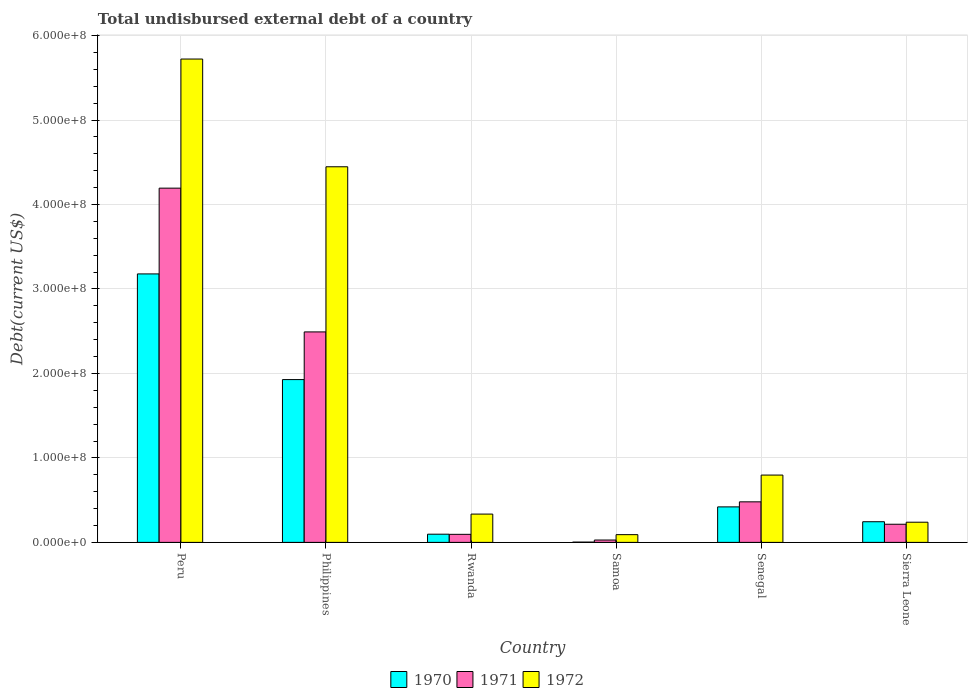How many groups of bars are there?
Offer a very short reply. 6. Are the number of bars on each tick of the X-axis equal?
Provide a short and direct response. Yes. What is the label of the 5th group of bars from the left?
Your answer should be compact. Senegal. In how many cases, is the number of bars for a given country not equal to the number of legend labels?
Your response must be concise. 0. What is the total undisbursed external debt in 1971 in Rwanda?
Keep it short and to the point. 9.53e+06. Across all countries, what is the maximum total undisbursed external debt in 1972?
Provide a short and direct response. 5.72e+08. Across all countries, what is the minimum total undisbursed external debt in 1972?
Provide a short and direct response. 9.15e+06. In which country was the total undisbursed external debt in 1970 minimum?
Offer a very short reply. Samoa. What is the total total undisbursed external debt in 1970 in the graph?
Make the answer very short. 5.87e+08. What is the difference between the total undisbursed external debt in 1972 in Peru and that in Sierra Leone?
Your response must be concise. 5.48e+08. What is the difference between the total undisbursed external debt in 1971 in Senegal and the total undisbursed external debt in 1970 in Rwanda?
Provide a succinct answer. 3.83e+07. What is the average total undisbursed external debt in 1972 per country?
Keep it short and to the point. 1.94e+08. What is the difference between the total undisbursed external debt of/in 1971 and total undisbursed external debt of/in 1972 in Peru?
Make the answer very short. -1.53e+08. What is the ratio of the total undisbursed external debt in 1971 in Samoa to that in Senegal?
Make the answer very short. 0.06. Is the difference between the total undisbursed external debt in 1971 in Peru and Philippines greater than the difference between the total undisbursed external debt in 1972 in Peru and Philippines?
Give a very brief answer. Yes. What is the difference between the highest and the second highest total undisbursed external debt in 1971?
Provide a short and direct response. 1.70e+08. What is the difference between the highest and the lowest total undisbursed external debt in 1971?
Provide a short and direct response. 4.17e+08. In how many countries, is the total undisbursed external debt in 1970 greater than the average total undisbursed external debt in 1970 taken over all countries?
Your answer should be very brief. 2. Is the sum of the total undisbursed external debt in 1971 in Rwanda and Sierra Leone greater than the maximum total undisbursed external debt in 1970 across all countries?
Offer a very short reply. No. What does the 1st bar from the right in Sierra Leone represents?
Provide a succinct answer. 1972. How many countries are there in the graph?
Keep it short and to the point. 6. What is the difference between two consecutive major ticks on the Y-axis?
Your answer should be compact. 1.00e+08. Are the values on the major ticks of Y-axis written in scientific E-notation?
Keep it short and to the point. Yes. Does the graph contain grids?
Your answer should be very brief. Yes. Where does the legend appear in the graph?
Ensure brevity in your answer.  Bottom center. How many legend labels are there?
Provide a succinct answer. 3. What is the title of the graph?
Offer a very short reply. Total undisbursed external debt of a country. What is the label or title of the X-axis?
Your answer should be very brief. Country. What is the label or title of the Y-axis?
Make the answer very short. Debt(current US$). What is the Debt(current US$) in 1970 in Peru?
Your answer should be compact. 3.18e+08. What is the Debt(current US$) of 1971 in Peru?
Your answer should be compact. 4.19e+08. What is the Debt(current US$) of 1972 in Peru?
Ensure brevity in your answer.  5.72e+08. What is the Debt(current US$) of 1970 in Philippines?
Your answer should be very brief. 1.93e+08. What is the Debt(current US$) of 1971 in Philippines?
Your answer should be very brief. 2.49e+08. What is the Debt(current US$) of 1972 in Philippines?
Your answer should be very brief. 4.45e+08. What is the Debt(current US$) of 1970 in Rwanda?
Provide a short and direct response. 9.70e+06. What is the Debt(current US$) in 1971 in Rwanda?
Your answer should be compact. 9.53e+06. What is the Debt(current US$) in 1972 in Rwanda?
Provide a succinct answer. 3.35e+07. What is the Debt(current US$) in 1970 in Samoa?
Offer a very short reply. 3.36e+05. What is the Debt(current US$) in 1971 in Samoa?
Ensure brevity in your answer.  2.80e+06. What is the Debt(current US$) of 1972 in Samoa?
Your answer should be compact. 9.15e+06. What is the Debt(current US$) of 1970 in Senegal?
Offer a terse response. 4.20e+07. What is the Debt(current US$) in 1971 in Senegal?
Keep it short and to the point. 4.80e+07. What is the Debt(current US$) of 1972 in Senegal?
Your response must be concise. 7.97e+07. What is the Debt(current US$) in 1970 in Sierra Leone?
Your response must be concise. 2.45e+07. What is the Debt(current US$) in 1971 in Sierra Leone?
Give a very brief answer. 2.15e+07. What is the Debt(current US$) in 1972 in Sierra Leone?
Make the answer very short. 2.39e+07. Across all countries, what is the maximum Debt(current US$) in 1970?
Make the answer very short. 3.18e+08. Across all countries, what is the maximum Debt(current US$) of 1971?
Provide a short and direct response. 4.19e+08. Across all countries, what is the maximum Debt(current US$) of 1972?
Offer a terse response. 5.72e+08. Across all countries, what is the minimum Debt(current US$) in 1970?
Keep it short and to the point. 3.36e+05. Across all countries, what is the minimum Debt(current US$) in 1971?
Provide a short and direct response. 2.80e+06. Across all countries, what is the minimum Debt(current US$) in 1972?
Give a very brief answer. 9.15e+06. What is the total Debt(current US$) of 1970 in the graph?
Keep it short and to the point. 5.87e+08. What is the total Debt(current US$) in 1971 in the graph?
Keep it short and to the point. 7.50e+08. What is the total Debt(current US$) of 1972 in the graph?
Offer a very short reply. 1.16e+09. What is the difference between the Debt(current US$) in 1970 in Peru and that in Philippines?
Your answer should be very brief. 1.25e+08. What is the difference between the Debt(current US$) in 1971 in Peru and that in Philippines?
Give a very brief answer. 1.70e+08. What is the difference between the Debt(current US$) in 1972 in Peru and that in Philippines?
Your answer should be very brief. 1.28e+08. What is the difference between the Debt(current US$) of 1970 in Peru and that in Rwanda?
Your response must be concise. 3.08e+08. What is the difference between the Debt(current US$) of 1971 in Peru and that in Rwanda?
Provide a succinct answer. 4.10e+08. What is the difference between the Debt(current US$) in 1972 in Peru and that in Rwanda?
Keep it short and to the point. 5.39e+08. What is the difference between the Debt(current US$) in 1970 in Peru and that in Samoa?
Make the answer very short. 3.17e+08. What is the difference between the Debt(current US$) in 1971 in Peru and that in Samoa?
Make the answer very short. 4.17e+08. What is the difference between the Debt(current US$) of 1972 in Peru and that in Samoa?
Give a very brief answer. 5.63e+08. What is the difference between the Debt(current US$) of 1970 in Peru and that in Senegal?
Provide a short and direct response. 2.76e+08. What is the difference between the Debt(current US$) in 1971 in Peru and that in Senegal?
Your response must be concise. 3.71e+08. What is the difference between the Debt(current US$) of 1972 in Peru and that in Senegal?
Your answer should be very brief. 4.92e+08. What is the difference between the Debt(current US$) of 1970 in Peru and that in Sierra Leone?
Provide a short and direct response. 2.93e+08. What is the difference between the Debt(current US$) of 1971 in Peru and that in Sierra Leone?
Ensure brevity in your answer.  3.98e+08. What is the difference between the Debt(current US$) in 1972 in Peru and that in Sierra Leone?
Provide a succinct answer. 5.48e+08. What is the difference between the Debt(current US$) in 1970 in Philippines and that in Rwanda?
Keep it short and to the point. 1.83e+08. What is the difference between the Debt(current US$) of 1971 in Philippines and that in Rwanda?
Offer a very short reply. 2.40e+08. What is the difference between the Debt(current US$) of 1972 in Philippines and that in Rwanda?
Give a very brief answer. 4.11e+08. What is the difference between the Debt(current US$) of 1970 in Philippines and that in Samoa?
Ensure brevity in your answer.  1.92e+08. What is the difference between the Debt(current US$) in 1971 in Philippines and that in Samoa?
Make the answer very short. 2.46e+08. What is the difference between the Debt(current US$) of 1972 in Philippines and that in Samoa?
Your response must be concise. 4.35e+08. What is the difference between the Debt(current US$) of 1970 in Philippines and that in Senegal?
Offer a very short reply. 1.51e+08. What is the difference between the Debt(current US$) in 1971 in Philippines and that in Senegal?
Your response must be concise. 2.01e+08. What is the difference between the Debt(current US$) in 1972 in Philippines and that in Senegal?
Offer a terse response. 3.65e+08. What is the difference between the Debt(current US$) in 1970 in Philippines and that in Sierra Leone?
Offer a terse response. 1.68e+08. What is the difference between the Debt(current US$) of 1971 in Philippines and that in Sierra Leone?
Ensure brevity in your answer.  2.28e+08. What is the difference between the Debt(current US$) of 1972 in Philippines and that in Sierra Leone?
Offer a terse response. 4.21e+08. What is the difference between the Debt(current US$) of 1970 in Rwanda and that in Samoa?
Offer a very short reply. 9.36e+06. What is the difference between the Debt(current US$) of 1971 in Rwanda and that in Samoa?
Your answer should be very brief. 6.73e+06. What is the difference between the Debt(current US$) in 1972 in Rwanda and that in Samoa?
Your response must be concise. 2.43e+07. What is the difference between the Debt(current US$) in 1970 in Rwanda and that in Senegal?
Ensure brevity in your answer.  -3.23e+07. What is the difference between the Debt(current US$) in 1971 in Rwanda and that in Senegal?
Your answer should be compact. -3.85e+07. What is the difference between the Debt(current US$) of 1972 in Rwanda and that in Senegal?
Offer a terse response. -4.62e+07. What is the difference between the Debt(current US$) in 1970 in Rwanda and that in Sierra Leone?
Offer a terse response. -1.48e+07. What is the difference between the Debt(current US$) of 1971 in Rwanda and that in Sierra Leone?
Offer a very short reply. -1.19e+07. What is the difference between the Debt(current US$) in 1972 in Rwanda and that in Sierra Leone?
Provide a short and direct response. 9.62e+06. What is the difference between the Debt(current US$) in 1970 in Samoa and that in Senegal?
Make the answer very short. -4.17e+07. What is the difference between the Debt(current US$) in 1971 in Samoa and that in Senegal?
Provide a succinct answer. -4.52e+07. What is the difference between the Debt(current US$) of 1972 in Samoa and that in Senegal?
Provide a short and direct response. -7.05e+07. What is the difference between the Debt(current US$) in 1970 in Samoa and that in Sierra Leone?
Keep it short and to the point. -2.41e+07. What is the difference between the Debt(current US$) in 1971 in Samoa and that in Sierra Leone?
Give a very brief answer. -1.87e+07. What is the difference between the Debt(current US$) in 1972 in Samoa and that in Sierra Leone?
Provide a succinct answer. -1.47e+07. What is the difference between the Debt(current US$) of 1970 in Senegal and that in Sierra Leone?
Your answer should be very brief. 1.76e+07. What is the difference between the Debt(current US$) of 1971 in Senegal and that in Sierra Leone?
Your answer should be very brief. 2.65e+07. What is the difference between the Debt(current US$) in 1972 in Senegal and that in Sierra Leone?
Give a very brief answer. 5.58e+07. What is the difference between the Debt(current US$) of 1970 in Peru and the Debt(current US$) of 1971 in Philippines?
Offer a very short reply. 6.86e+07. What is the difference between the Debt(current US$) of 1970 in Peru and the Debt(current US$) of 1972 in Philippines?
Make the answer very short. -1.27e+08. What is the difference between the Debt(current US$) in 1971 in Peru and the Debt(current US$) in 1972 in Philippines?
Ensure brevity in your answer.  -2.53e+07. What is the difference between the Debt(current US$) in 1970 in Peru and the Debt(current US$) in 1971 in Rwanda?
Make the answer very short. 3.08e+08. What is the difference between the Debt(current US$) in 1970 in Peru and the Debt(current US$) in 1972 in Rwanda?
Provide a short and direct response. 2.84e+08. What is the difference between the Debt(current US$) of 1971 in Peru and the Debt(current US$) of 1972 in Rwanda?
Give a very brief answer. 3.86e+08. What is the difference between the Debt(current US$) of 1970 in Peru and the Debt(current US$) of 1971 in Samoa?
Provide a short and direct response. 3.15e+08. What is the difference between the Debt(current US$) in 1970 in Peru and the Debt(current US$) in 1972 in Samoa?
Offer a very short reply. 3.09e+08. What is the difference between the Debt(current US$) of 1971 in Peru and the Debt(current US$) of 1972 in Samoa?
Keep it short and to the point. 4.10e+08. What is the difference between the Debt(current US$) of 1970 in Peru and the Debt(current US$) of 1971 in Senegal?
Give a very brief answer. 2.70e+08. What is the difference between the Debt(current US$) in 1970 in Peru and the Debt(current US$) in 1972 in Senegal?
Provide a short and direct response. 2.38e+08. What is the difference between the Debt(current US$) in 1971 in Peru and the Debt(current US$) in 1972 in Senegal?
Make the answer very short. 3.40e+08. What is the difference between the Debt(current US$) in 1970 in Peru and the Debt(current US$) in 1971 in Sierra Leone?
Your response must be concise. 2.96e+08. What is the difference between the Debt(current US$) in 1970 in Peru and the Debt(current US$) in 1972 in Sierra Leone?
Provide a succinct answer. 2.94e+08. What is the difference between the Debt(current US$) of 1971 in Peru and the Debt(current US$) of 1972 in Sierra Leone?
Your answer should be compact. 3.95e+08. What is the difference between the Debt(current US$) in 1970 in Philippines and the Debt(current US$) in 1971 in Rwanda?
Your response must be concise. 1.83e+08. What is the difference between the Debt(current US$) of 1970 in Philippines and the Debt(current US$) of 1972 in Rwanda?
Provide a succinct answer. 1.59e+08. What is the difference between the Debt(current US$) in 1971 in Philippines and the Debt(current US$) in 1972 in Rwanda?
Make the answer very short. 2.16e+08. What is the difference between the Debt(current US$) of 1970 in Philippines and the Debt(current US$) of 1971 in Samoa?
Your response must be concise. 1.90e+08. What is the difference between the Debt(current US$) of 1970 in Philippines and the Debt(current US$) of 1972 in Samoa?
Your answer should be very brief. 1.84e+08. What is the difference between the Debt(current US$) of 1971 in Philippines and the Debt(current US$) of 1972 in Samoa?
Offer a very short reply. 2.40e+08. What is the difference between the Debt(current US$) of 1970 in Philippines and the Debt(current US$) of 1971 in Senegal?
Provide a short and direct response. 1.45e+08. What is the difference between the Debt(current US$) of 1970 in Philippines and the Debt(current US$) of 1972 in Senegal?
Keep it short and to the point. 1.13e+08. What is the difference between the Debt(current US$) in 1971 in Philippines and the Debt(current US$) in 1972 in Senegal?
Your answer should be very brief. 1.69e+08. What is the difference between the Debt(current US$) of 1970 in Philippines and the Debt(current US$) of 1971 in Sierra Leone?
Keep it short and to the point. 1.71e+08. What is the difference between the Debt(current US$) of 1970 in Philippines and the Debt(current US$) of 1972 in Sierra Leone?
Your response must be concise. 1.69e+08. What is the difference between the Debt(current US$) of 1971 in Philippines and the Debt(current US$) of 1972 in Sierra Leone?
Keep it short and to the point. 2.25e+08. What is the difference between the Debt(current US$) in 1970 in Rwanda and the Debt(current US$) in 1971 in Samoa?
Keep it short and to the point. 6.90e+06. What is the difference between the Debt(current US$) of 1970 in Rwanda and the Debt(current US$) of 1972 in Samoa?
Ensure brevity in your answer.  5.45e+05. What is the difference between the Debt(current US$) of 1971 in Rwanda and the Debt(current US$) of 1972 in Samoa?
Offer a terse response. 3.82e+05. What is the difference between the Debt(current US$) of 1970 in Rwanda and the Debt(current US$) of 1971 in Senegal?
Your answer should be very brief. -3.83e+07. What is the difference between the Debt(current US$) of 1970 in Rwanda and the Debt(current US$) of 1972 in Senegal?
Provide a succinct answer. -7.00e+07. What is the difference between the Debt(current US$) of 1971 in Rwanda and the Debt(current US$) of 1972 in Senegal?
Offer a terse response. -7.02e+07. What is the difference between the Debt(current US$) of 1970 in Rwanda and the Debt(current US$) of 1971 in Sierra Leone?
Provide a short and direct response. -1.18e+07. What is the difference between the Debt(current US$) of 1970 in Rwanda and the Debt(current US$) of 1972 in Sierra Leone?
Ensure brevity in your answer.  -1.42e+07. What is the difference between the Debt(current US$) in 1971 in Rwanda and the Debt(current US$) in 1972 in Sierra Leone?
Your answer should be compact. -1.43e+07. What is the difference between the Debt(current US$) of 1970 in Samoa and the Debt(current US$) of 1971 in Senegal?
Your response must be concise. -4.77e+07. What is the difference between the Debt(current US$) of 1970 in Samoa and the Debt(current US$) of 1972 in Senegal?
Your response must be concise. -7.93e+07. What is the difference between the Debt(current US$) in 1971 in Samoa and the Debt(current US$) in 1972 in Senegal?
Ensure brevity in your answer.  -7.69e+07. What is the difference between the Debt(current US$) in 1970 in Samoa and the Debt(current US$) in 1971 in Sierra Leone?
Your answer should be compact. -2.11e+07. What is the difference between the Debt(current US$) of 1970 in Samoa and the Debt(current US$) of 1972 in Sierra Leone?
Make the answer very short. -2.35e+07. What is the difference between the Debt(current US$) of 1971 in Samoa and the Debt(current US$) of 1972 in Sierra Leone?
Your response must be concise. -2.11e+07. What is the difference between the Debt(current US$) in 1970 in Senegal and the Debt(current US$) in 1971 in Sierra Leone?
Ensure brevity in your answer.  2.05e+07. What is the difference between the Debt(current US$) in 1970 in Senegal and the Debt(current US$) in 1972 in Sierra Leone?
Make the answer very short. 1.82e+07. What is the difference between the Debt(current US$) of 1971 in Senegal and the Debt(current US$) of 1972 in Sierra Leone?
Offer a very short reply. 2.41e+07. What is the average Debt(current US$) of 1970 per country?
Offer a very short reply. 9.78e+07. What is the average Debt(current US$) in 1971 per country?
Ensure brevity in your answer.  1.25e+08. What is the average Debt(current US$) in 1972 per country?
Offer a terse response. 1.94e+08. What is the difference between the Debt(current US$) in 1970 and Debt(current US$) in 1971 in Peru?
Offer a terse response. -1.02e+08. What is the difference between the Debt(current US$) in 1970 and Debt(current US$) in 1972 in Peru?
Offer a terse response. -2.54e+08. What is the difference between the Debt(current US$) of 1971 and Debt(current US$) of 1972 in Peru?
Ensure brevity in your answer.  -1.53e+08. What is the difference between the Debt(current US$) of 1970 and Debt(current US$) of 1971 in Philippines?
Offer a terse response. -5.64e+07. What is the difference between the Debt(current US$) of 1970 and Debt(current US$) of 1972 in Philippines?
Ensure brevity in your answer.  -2.52e+08. What is the difference between the Debt(current US$) in 1971 and Debt(current US$) in 1972 in Philippines?
Offer a terse response. -1.95e+08. What is the difference between the Debt(current US$) of 1970 and Debt(current US$) of 1971 in Rwanda?
Offer a terse response. 1.63e+05. What is the difference between the Debt(current US$) of 1970 and Debt(current US$) of 1972 in Rwanda?
Offer a terse response. -2.38e+07. What is the difference between the Debt(current US$) in 1971 and Debt(current US$) in 1972 in Rwanda?
Offer a terse response. -2.40e+07. What is the difference between the Debt(current US$) of 1970 and Debt(current US$) of 1971 in Samoa?
Offer a very short reply. -2.46e+06. What is the difference between the Debt(current US$) of 1970 and Debt(current US$) of 1972 in Samoa?
Keep it short and to the point. -8.82e+06. What is the difference between the Debt(current US$) in 1971 and Debt(current US$) in 1972 in Samoa?
Your response must be concise. -6.35e+06. What is the difference between the Debt(current US$) in 1970 and Debt(current US$) in 1971 in Senegal?
Offer a very short reply. -5.97e+06. What is the difference between the Debt(current US$) of 1970 and Debt(current US$) of 1972 in Senegal?
Your response must be concise. -3.77e+07. What is the difference between the Debt(current US$) in 1971 and Debt(current US$) in 1972 in Senegal?
Ensure brevity in your answer.  -3.17e+07. What is the difference between the Debt(current US$) in 1970 and Debt(current US$) in 1971 in Sierra Leone?
Your answer should be very brief. 2.98e+06. What is the difference between the Debt(current US$) of 1970 and Debt(current US$) of 1972 in Sierra Leone?
Keep it short and to the point. 5.82e+05. What is the difference between the Debt(current US$) of 1971 and Debt(current US$) of 1972 in Sierra Leone?
Your answer should be very brief. -2.40e+06. What is the ratio of the Debt(current US$) of 1970 in Peru to that in Philippines?
Offer a very short reply. 1.65. What is the ratio of the Debt(current US$) of 1971 in Peru to that in Philippines?
Give a very brief answer. 1.68. What is the ratio of the Debt(current US$) of 1972 in Peru to that in Philippines?
Provide a short and direct response. 1.29. What is the ratio of the Debt(current US$) of 1970 in Peru to that in Rwanda?
Your answer should be compact. 32.78. What is the ratio of the Debt(current US$) of 1971 in Peru to that in Rwanda?
Your answer should be very brief. 43.99. What is the ratio of the Debt(current US$) in 1972 in Peru to that in Rwanda?
Your answer should be very brief. 17.08. What is the ratio of the Debt(current US$) in 1970 in Peru to that in Samoa?
Offer a very short reply. 945.85. What is the ratio of the Debt(current US$) of 1971 in Peru to that in Samoa?
Make the answer very short. 149.71. What is the ratio of the Debt(current US$) in 1972 in Peru to that in Samoa?
Your response must be concise. 62.53. What is the ratio of the Debt(current US$) in 1970 in Peru to that in Senegal?
Keep it short and to the point. 7.56. What is the ratio of the Debt(current US$) of 1971 in Peru to that in Senegal?
Keep it short and to the point. 8.74. What is the ratio of the Debt(current US$) in 1972 in Peru to that in Senegal?
Offer a very short reply. 7.18. What is the ratio of the Debt(current US$) in 1970 in Peru to that in Sierra Leone?
Your response must be concise. 12.99. What is the ratio of the Debt(current US$) of 1971 in Peru to that in Sierra Leone?
Ensure brevity in your answer.  19.53. What is the ratio of the Debt(current US$) in 1972 in Peru to that in Sierra Leone?
Keep it short and to the point. 23.97. What is the ratio of the Debt(current US$) of 1970 in Philippines to that in Rwanda?
Make the answer very short. 19.88. What is the ratio of the Debt(current US$) in 1971 in Philippines to that in Rwanda?
Make the answer very short. 26.14. What is the ratio of the Debt(current US$) in 1972 in Philippines to that in Rwanda?
Your answer should be compact. 13.28. What is the ratio of the Debt(current US$) of 1970 in Philippines to that in Samoa?
Your response must be concise. 573.59. What is the ratio of the Debt(current US$) of 1971 in Philippines to that in Samoa?
Make the answer very short. 88.95. What is the ratio of the Debt(current US$) in 1972 in Philippines to that in Samoa?
Offer a very short reply. 48.59. What is the ratio of the Debt(current US$) in 1970 in Philippines to that in Senegal?
Ensure brevity in your answer.  4.59. What is the ratio of the Debt(current US$) of 1971 in Philippines to that in Senegal?
Offer a very short reply. 5.19. What is the ratio of the Debt(current US$) in 1972 in Philippines to that in Senegal?
Your answer should be very brief. 5.58. What is the ratio of the Debt(current US$) in 1970 in Philippines to that in Sierra Leone?
Offer a terse response. 7.88. What is the ratio of the Debt(current US$) in 1971 in Philippines to that in Sierra Leone?
Offer a very short reply. 11.6. What is the ratio of the Debt(current US$) in 1972 in Philippines to that in Sierra Leone?
Offer a terse response. 18.62. What is the ratio of the Debt(current US$) in 1970 in Rwanda to that in Samoa?
Your answer should be very brief. 28.86. What is the ratio of the Debt(current US$) of 1971 in Rwanda to that in Samoa?
Keep it short and to the point. 3.4. What is the ratio of the Debt(current US$) of 1972 in Rwanda to that in Samoa?
Make the answer very short. 3.66. What is the ratio of the Debt(current US$) in 1970 in Rwanda to that in Senegal?
Ensure brevity in your answer.  0.23. What is the ratio of the Debt(current US$) in 1971 in Rwanda to that in Senegal?
Your response must be concise. 0.2. What is the ratio of the Debt(current US$) in 1972 in Rwanda to that in Senegal?
Provide a short and direct response. 0.42. What is the ratio of the Debt(current US$) in 1970 in Rwanda to that in Sierra Leone?
Keep it short and to the point. 0.4. What is the ratio of the Debt(current US$) in 1971 in Rwanda to that in Sierra Leone?
Your answer should be very brief. 0.44. What is the ratio of the Debt(current US$) in 1972 in Rwanda to that in Sierra Leone?
Offer a terse response. 1.4. What is the ratio of the Debt(current US$) in 1970 in Samoa to that in Senegal?
Your response must be concise. 0.01. What is the ratio of the Debt(current US$) of 1971 in Samoa to that in Senegal?
Keep it short and to the point. 0.06. What is the ratio of the Debt(current US$) in 1972 in Samoa to that in Senegal?
Ensure brevity in your answer.  0.11. What is the ratio of the Debt(current US$) in 1970 in Samoa to that in Sierra Leone?
Make the answer very short. 0.01. What is the ratio of the Debt(current US$) of 1971 in Samoa to that in Sierra Leone?
Offer a terse response. 0.13. What is the ratio of the Debt(current US$) of 1972 in Samoa to that in Sierra Leone?
Provide a short and direct response. 0.38. What is the ratio of the Debt(current US$) in 1970 in Senegal to that in Sierra Leone?
Keep it short and to the point. 1.72. What is the ratio of the Debt(current US$) in 1971 in Senegal to that in Sierra Leone?
Give a very brief answer. 2.23. What is the ratio of the Debt(current US$) in 1972 in Senegal to that in Sierra Leone?
Make the answer very short. 3.34. What is the difference between the highest and the second highest Debt(current US$) in 1970?
Your response must be concise. 1.25e+08. What is the difference between the highest and the second highest Debt(current US$) of 1971?
Offer a terse response. 1.70e+08. What is the difference between the highest and the second highest Debt(current US$) in 1972?
Provide a succinct answer. 1.28e+08. What is the difference between the highest and the lowest Debt(current US$) of 1970?
Make the answer very short. 3.17e+08. What is the difference between the highest and the lowest Debt(current US$) in 1971?
Make the answer very short. 4.17e+08. What is the difference between the highest and the lowest Debt(current US$) of 1972?
Make the answer very short. 5.63e+08. 